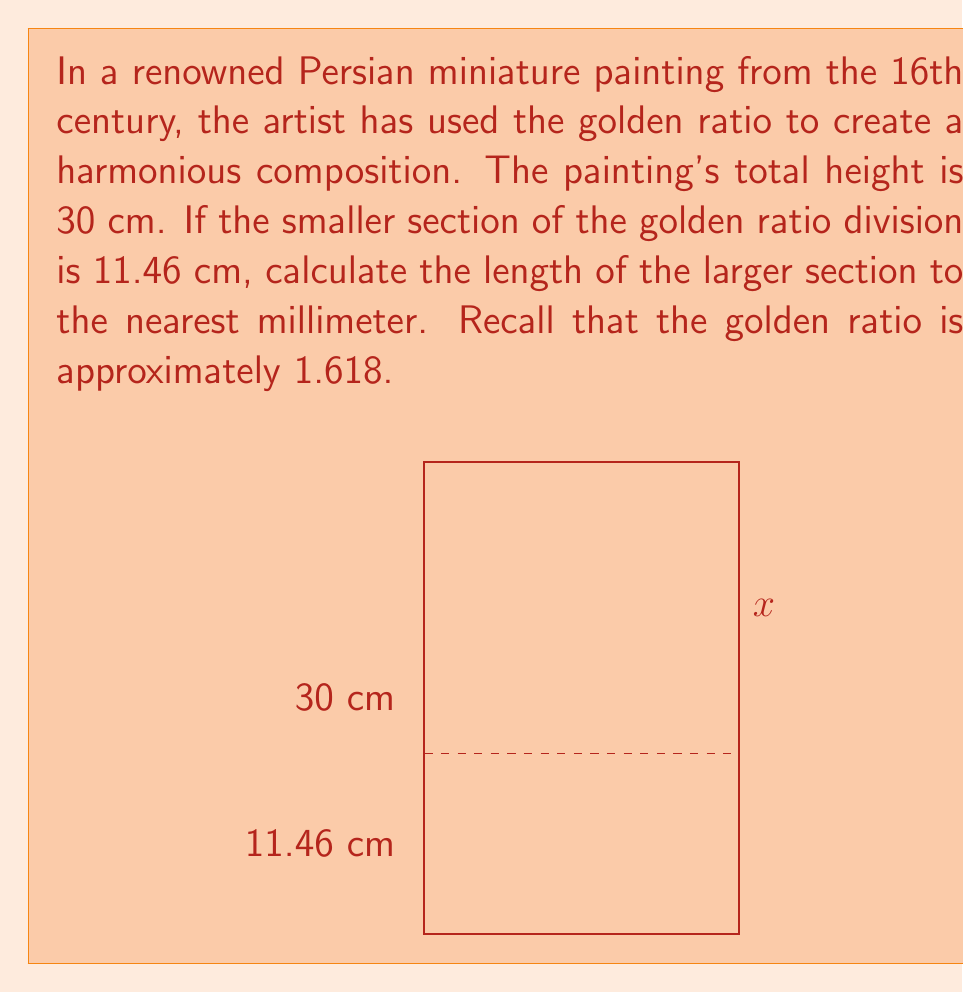Solve this math problem. Let's approach this step-by-step:

1) The golden ratio is defined as the ratio of the larger part to the smaller part, which is equal to the ratio of the whole to the larger part. Let's call the larger part $x$.

2) We can express this mathematically as:
   $$\frac{x}{11.46} = \frac{30}{x} = \phi \approx 1.618$$

3) We can solve this equation for $x$:
   $$x = 11.46 \times 1.618 = 18.54228$$

4) Alternatively, we could have used the property that in a golden ratio division, the larger part is the total length minus the smaller part:
   $$x = 30 - 11.46 = 18.54$$

5) Both methods yield the same result. Rounding to the nearest millimeter:
   $$x \approx 18.54 \text{ cm}$$

This demonstrates how the golden ratio (φ ≈ 1.618) is applied in the composition of Persian miniature paintings, creating a balance that is often perceived as aesthetically pleasing.
Answer: 18.54 cm 